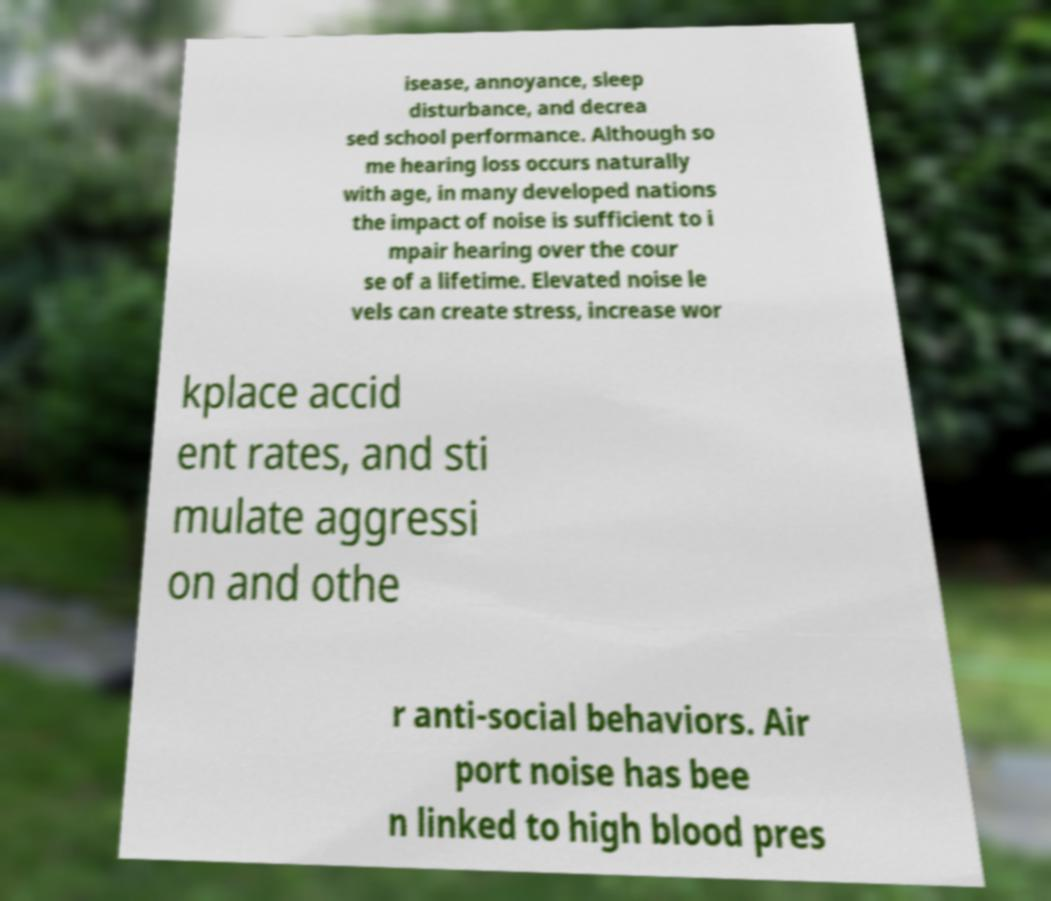Please read and relay the text visible in this image. What does it say? isease, annoyance, sleep disturbance, and decrea sed school performance. Although so me hearing loss occurs naturally with age, in many developed nations the impact of noise is sufficient to i mpair hearing over the cour se of a lifetime. Elevated noise le vels can create stress, increase wor kplace accid ent rates, and sti mulate aggressi on and othe r anti-social behaviors. Air port noise has bee n linked to high blood pres 